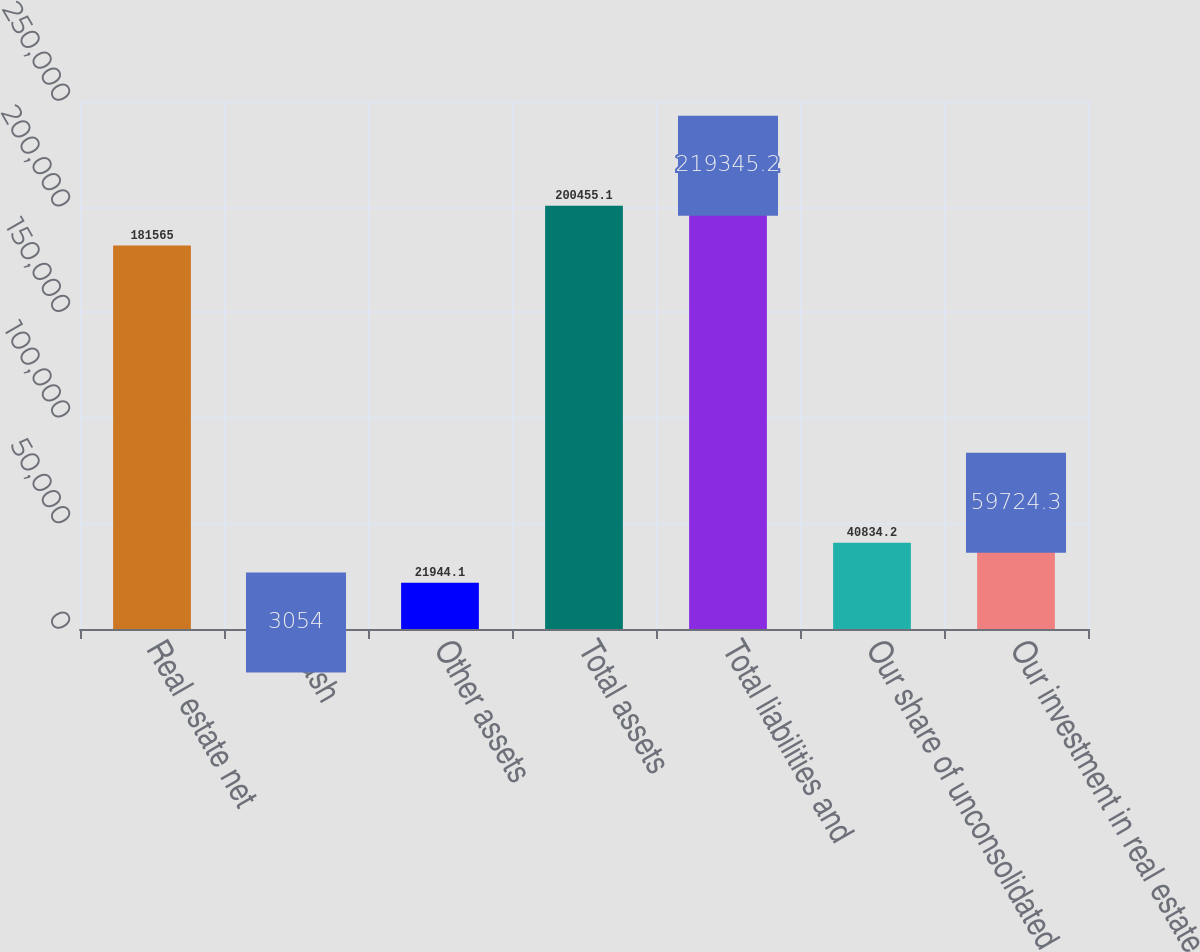<chart> <loc_0><loc_0><loc_500><loc_500><bar_chart><fcel>Real estate net<fcel>Cash<fcel>Other assets<fcel>Total assets<fcel>Total liabilities and<fcel>Our share of unconsolidated<fcel>Our investment in real estate<nl><fcel>181565<fcel>3054<fcel>21944.1<fcel>200455<fcel>219345<fcel>40834.2<fcel>59724.3<nl></chart> 